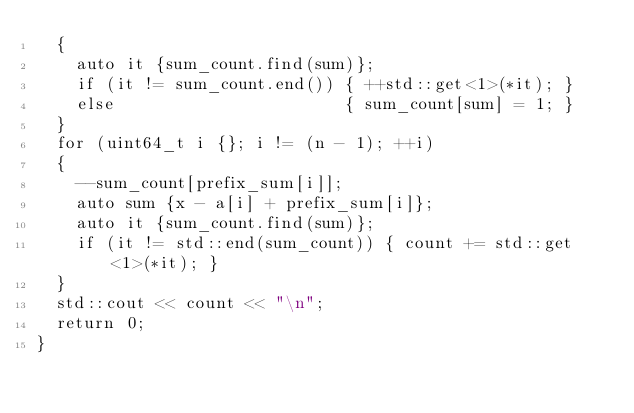Convert code to text. <code><loc_0><loc_0><loc_500><loc_500><_C++_>  {
    auto it {sum_count.find(sum)};
    if (it != sum_count.end()) { ++std::get<1>(*it); }
    else                       { sum_count[sum] = 1; }
  }
  for (uint64_t i {}; i != (n - 1); ++i)
  {
    --sum_count[prefix_sum[i]];
    auto sum {x - a[i] + prefix_sum[i]};
    auto it {sum_count.find(sum)};
    if (it != std::end(sum_count)) { count += std::get<1>(*it); }
  }
  std::cout << count << "\n";
  return 0;
}</code> 